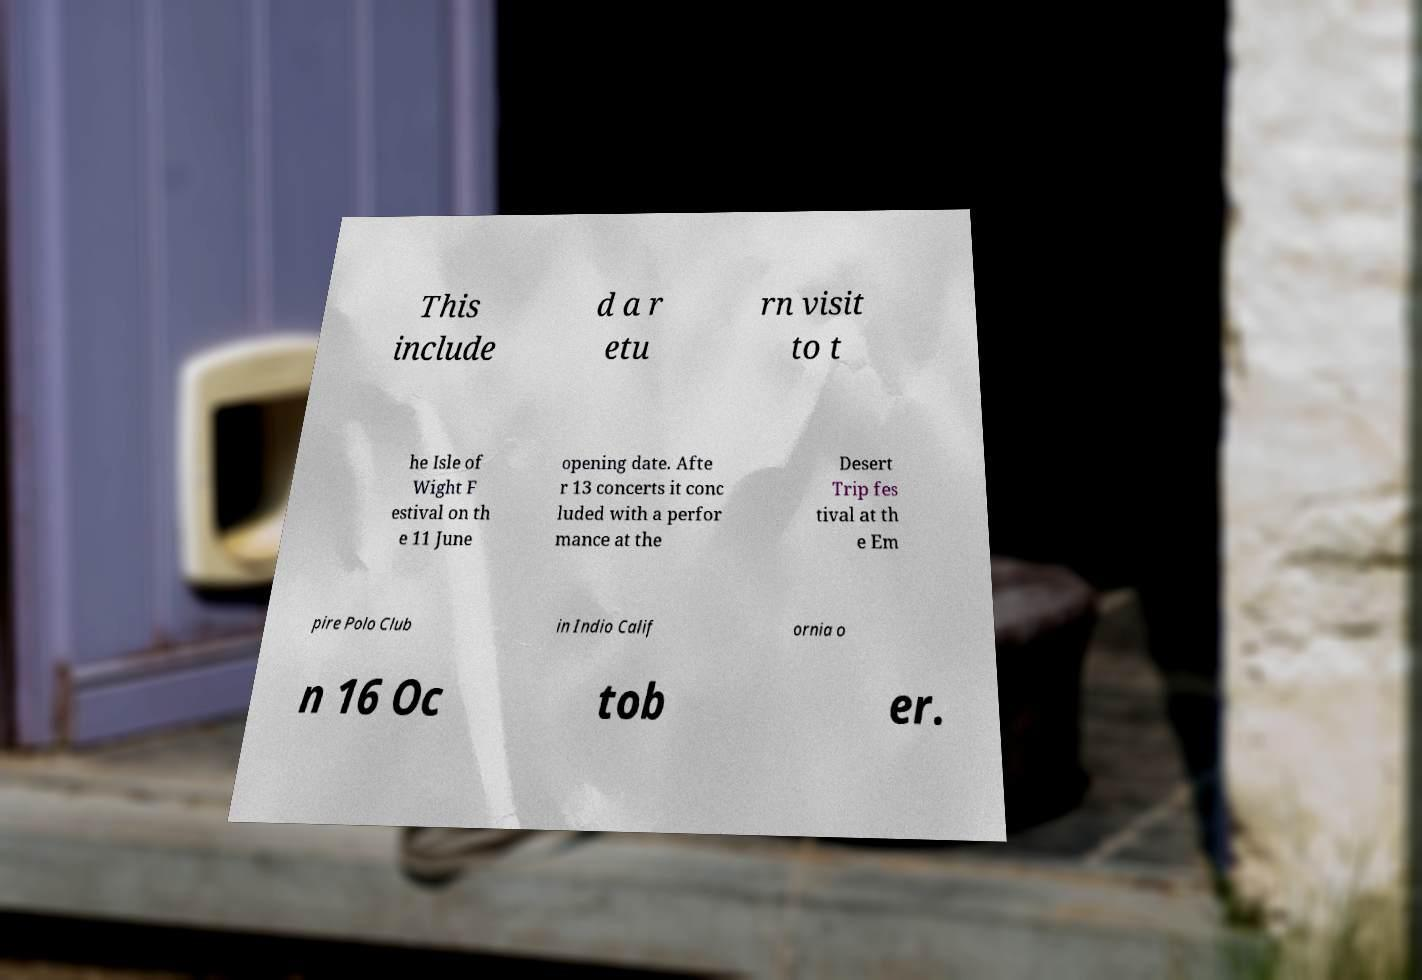Please read and relay the text visible in this image. What does it say? This include d a r etu rn visit to t he Isle of Wight F estival on th e 11 June opening date. Afte r 13 concerts it conc luded with a perfor mance at the Desert Trip fes tival at th e Em pire Polo Club in Indio Calif ornia o n 16 Oc tob er. 